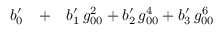<formula> <loc_0><loc_0><loc_500><loc_500>\begin{array} { r l r } { b _ { 0 } ^ { \prime } } & + } & { b _ { 1 } ^ { \prime } \, g _ { 0 0 } ^ { 2 } + b _ { 2 } ^ { \prime } \, g _ { 0 0 } ^ { 4 } + b _ { 3 } ^ { \prime } \, g _ { 0 0 } ^ { 6 } } \end{array}</formula> 